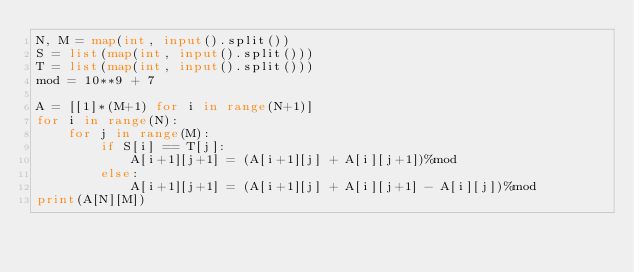Convert code to text. <code><loc_0><loc_0><loc_500><loc_500><_Python_>N, M = map(int, input().split())
S = list(map(int, input().split()))
T = list(map(int, input().split()))
mod = 10**9 + 7

A = [[1]*(M+1) for i in range(N+1)]
for i in range(N):
    for j in range(M):
        if S[i] == T[j]:
            A[i+1][j+1] = (A[i+1][j] + A[i][j+1])%mod
        else:
            A[i+1][j+1] = (A[i+1][j] + A[i][j+1] - A[i][j])%mod
print(A[N][M])

</code> 